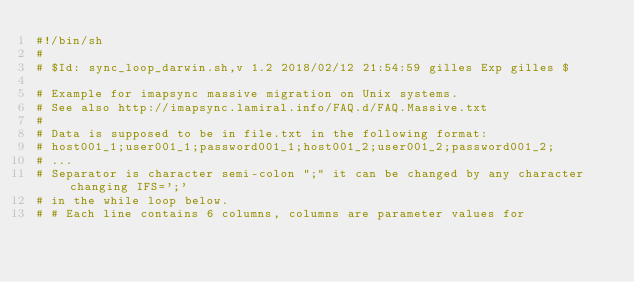<code> <loc_0><loc_0><loc_500><loc_500><_Bash_>#!/bin/sh
#
# $Id: sync_loop_darwin.sh,v 1.2 2018/02/12 21:54:59 gilles Exp gilles $

# Example for imapsync massive migration on Unix systems.
# See also http://imapsync.lamiral.info/FAQ.d/FAQ.Massive.txt
#
# Data is supposed to be in file.txt in the following format:
# host001_1;user001_1;password001_1;host001_2;user001_2;password001_2;
# ...
# Separator is character semi-colon ";" it can be changed by any character changing IFS=';' 
# in the while loop below.
# # Each line contains 6 columns, columns are parameter values for </code> 